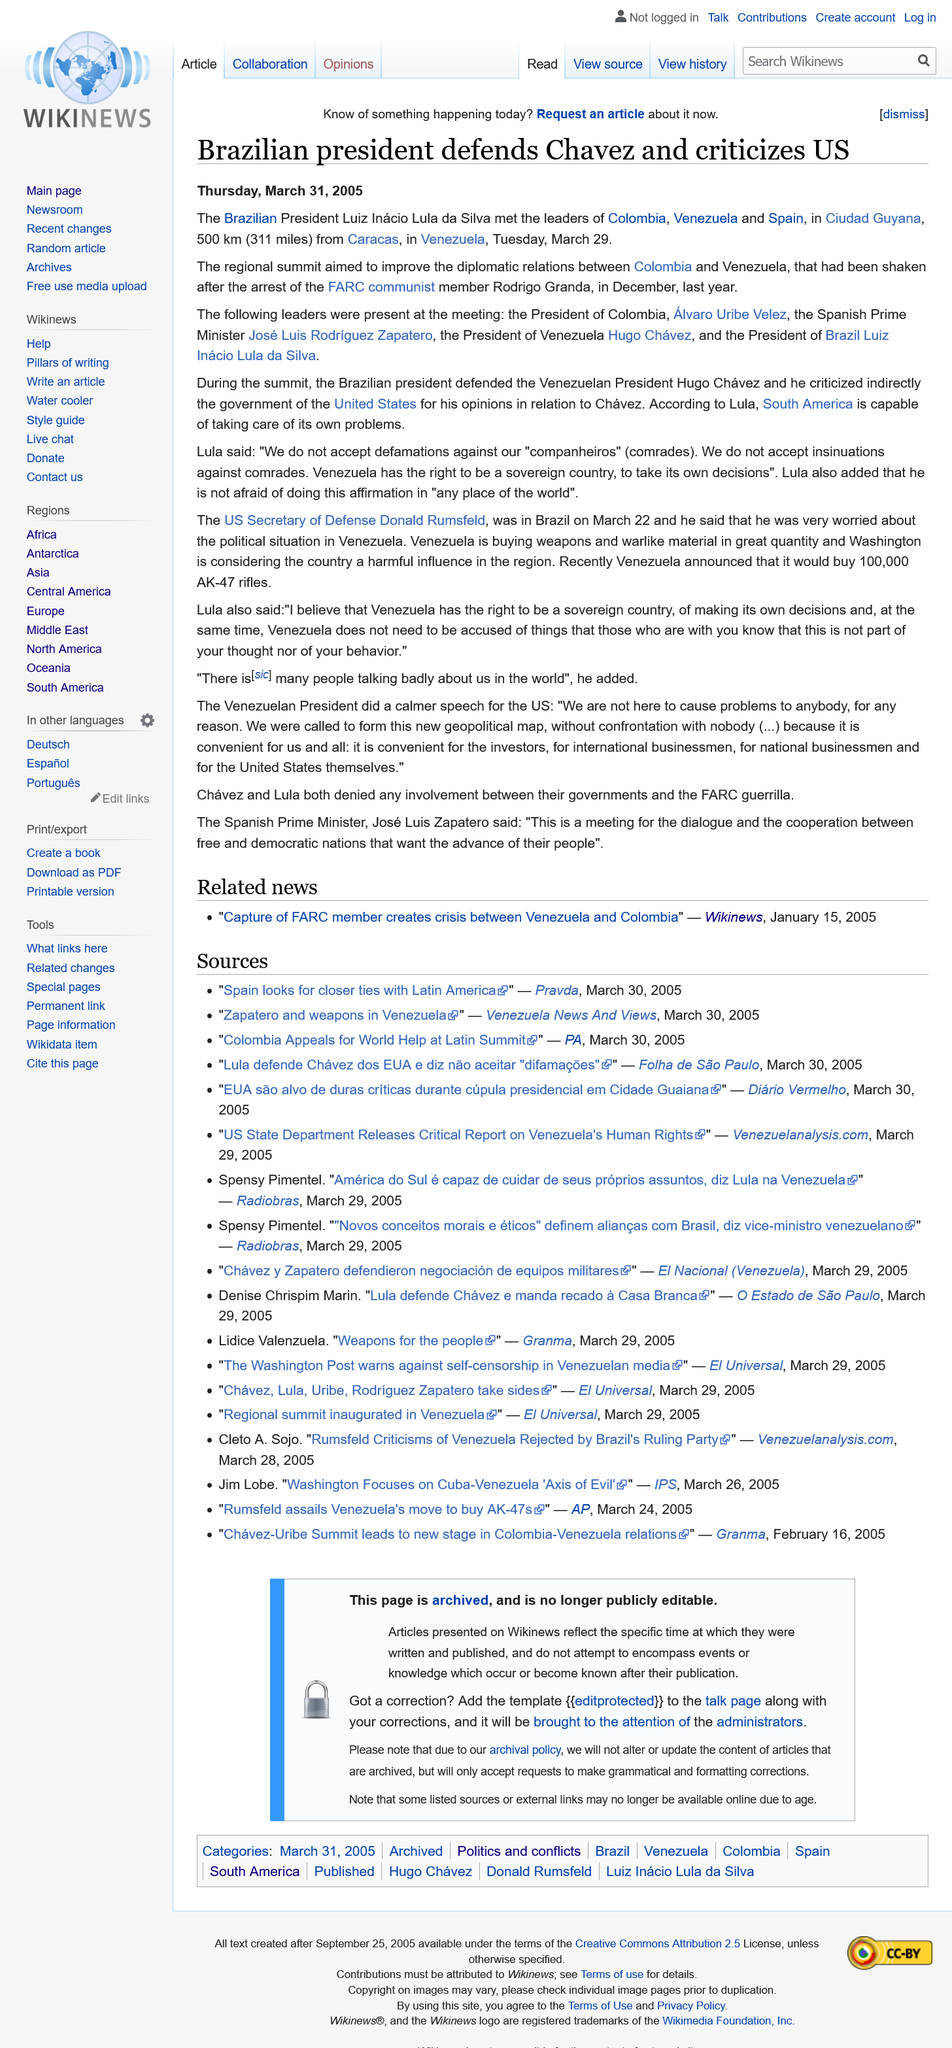List a handful of essential elements in this visual. Ciudad Guyana is located 500 kilometers (311 miles) from Caracas, the capital city of Venezuela. The President of Brazil met with the leaders of Colombia, Venezuela, and Spain. Luiz Inacio Lula da Silva, the President of Brazil, defended Hugo Chavez. 